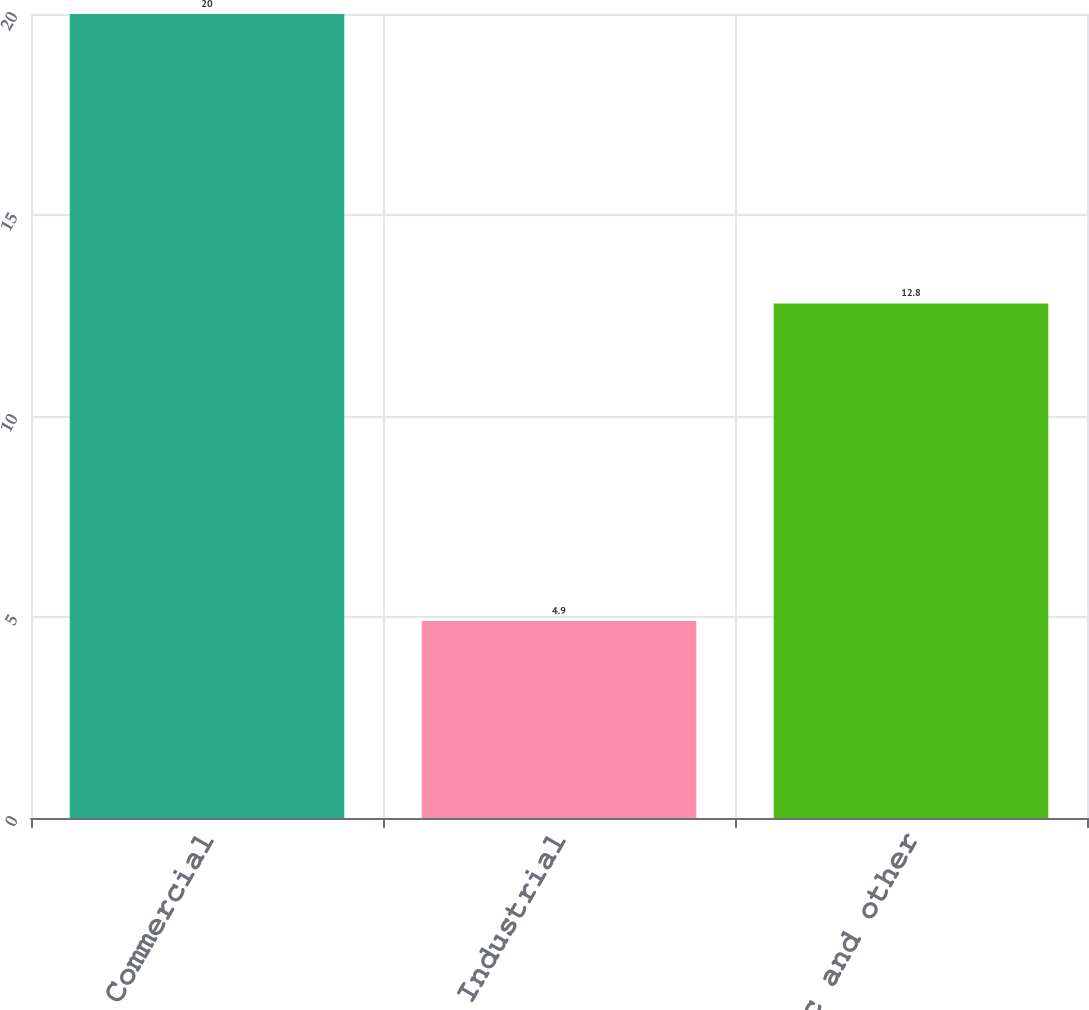Convert chart to OTSL. <chart><loc_0><loc_0><loc_500><loc_500><bar_chart><fcel>Commercial<fcel>Industrial<fcel>Public and other<nl><fcel>20<fcel>4.9<fcel>12.8<nl></chart> 